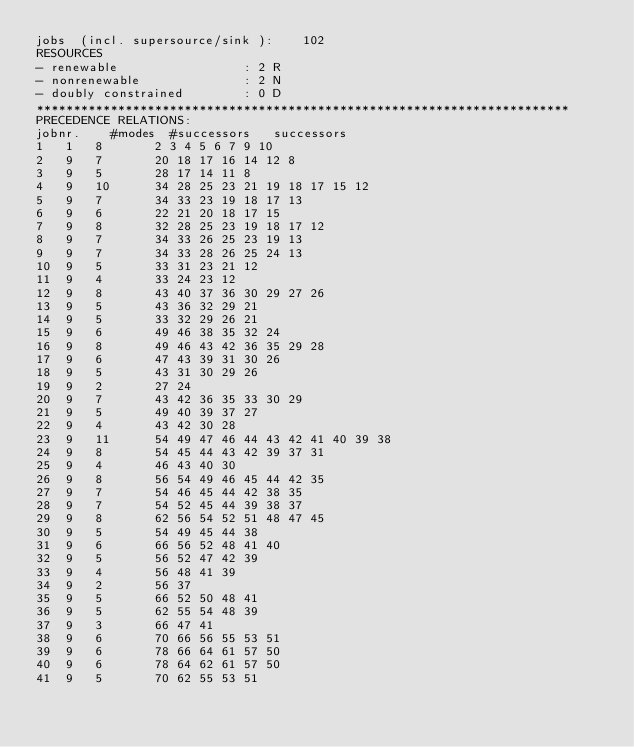<code> <loc_0><loc_0><loc_500><loc_500><_ObjectiveC_>jobs  (incl. supersource/sink ):	102
RESOURCES
- renewable                 : 2 R
- nonrenewable              : 2 N
- doubly constrained        : 0 D
************************************************************************
PRECEDENCE RELATIONS:
jobnr.    #modes  #successors   successors
1	1	8		2 3 4 5 6 7 9 10 
2	9	7		20 18 17 16 14 12 8 
3	9	5		28 17 14 11 8 
4	9	10		34 28 25 23 21 19 18 17 15 12 
5	9	7		34 33 23 19 18 17 13 
6	9	6		22 21 20 18 17 15 
7	9	8		32 28 25 23 19 18 17 12 
8	9	7		34 33 26 25 23 19 13 
9	9	7		34 33 28 26 25 24 13 
10	9	5		33 31 23 21 12 
11	9	4		33 24 23 12 
12	9	8		43 40 37 36 30 29 27 26 
13	9	5		43 36 32 29 21 
14	9	5		33 32 29 26 21 
15	9	6		49 46 38 35 32 24 
16	9	8		49 46 43 42 36 35 29 28 
17	9	6		47 43 39 31 30 26 
18	9	5		43 31 30 29 26 
19	9	2		27 24 
20	9	7		43 42 36 35 33 30 29 
21	9	5		49 40 39 37 27 
22	9	4		43 42 30 28 
23	9	11		54 49 47 46 44 43 42 41 40 39 38 
24	9	8		54 45 44 43 42 39 37 31 
25	9	4		46 43 40 30 
26	9	8		56 54 49 46 45 44 42 35 
27	9	7		54 46 45 44 42 38 35 
28	9	7		54 52 45 44 39 38 37 
29	9	8		62 56 54 52 51 48 47 45 
30	9	5		54 49 45 44 38 
31	9	6		66 56 52 48 41 40 
32	9	5		56 52 47 42 39 
33	9	4		56 48 41 39 
34	9	2		56 37 
35	9	5		66 52 50 48 41 
36	9	5		62 55 54 48 39 
37	9	3		66 47 41 
38	9	6		70 66 56 55 53 51 
39	9	6		78 66 64 61 57 50 
40	9	6		78 64 62 61 57 50 
41	9	5		70 62 55 53 51 </code> 